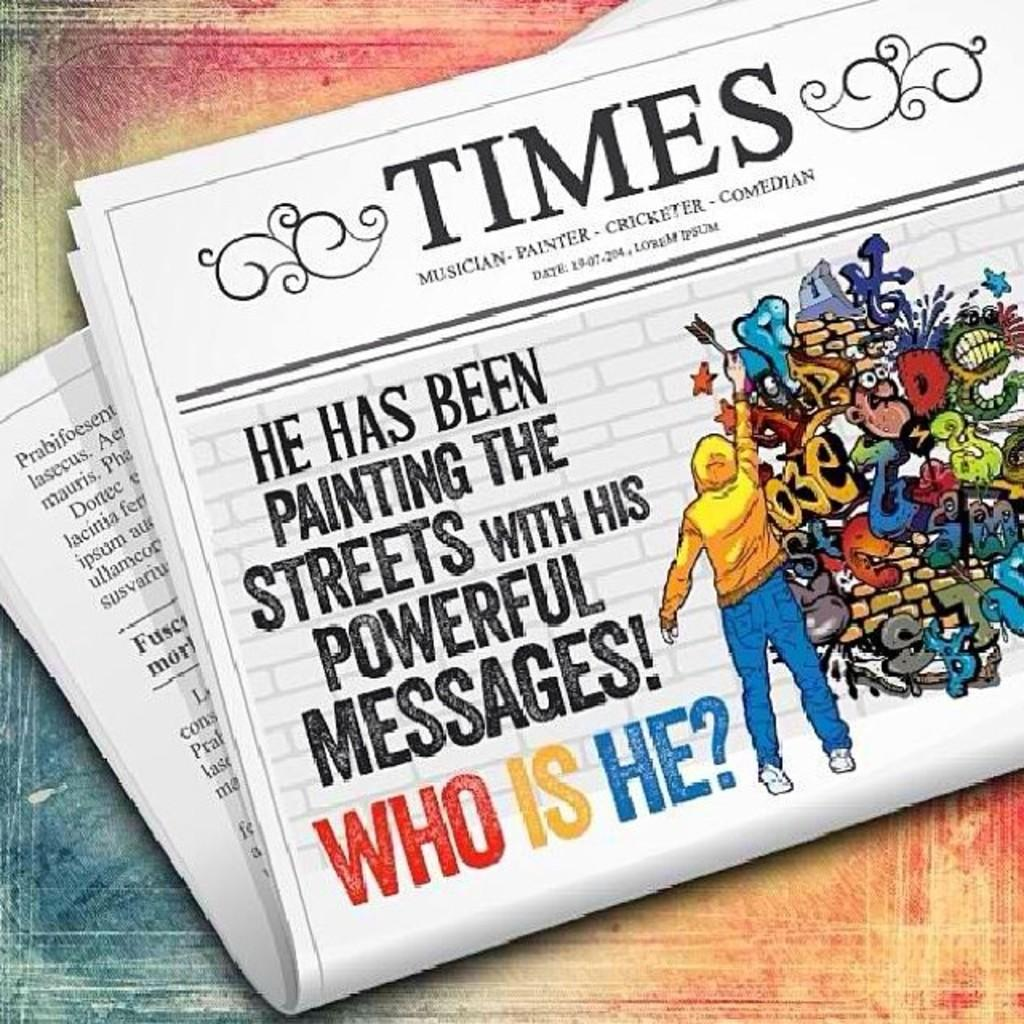<image>
Relay a brief, clear account of the picture shown. An issue of a newspaper includes a story about an artist who has been painting the streets. 